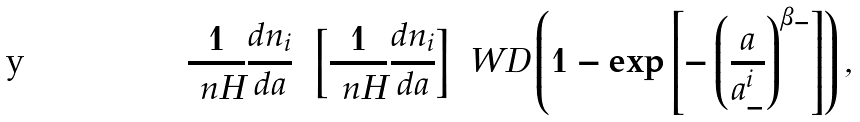Convert formula to latex. <formula><loc_0><loc_0><loc_500><loc_500>\frac { 1 } { \ n H } \frac { d n _ { i } } { d a } = \left [ \frac { 1 } { \ n H } \frac { d n _ { i } } { d a } \right ] _ { \ } W D \left ( 1 - \exp { \left [ - \left ( \frac { a } { a _ { - } ^ { i } } \right ) ^ { \beta _ { - } } \right ] } \right ) ,</formula> 